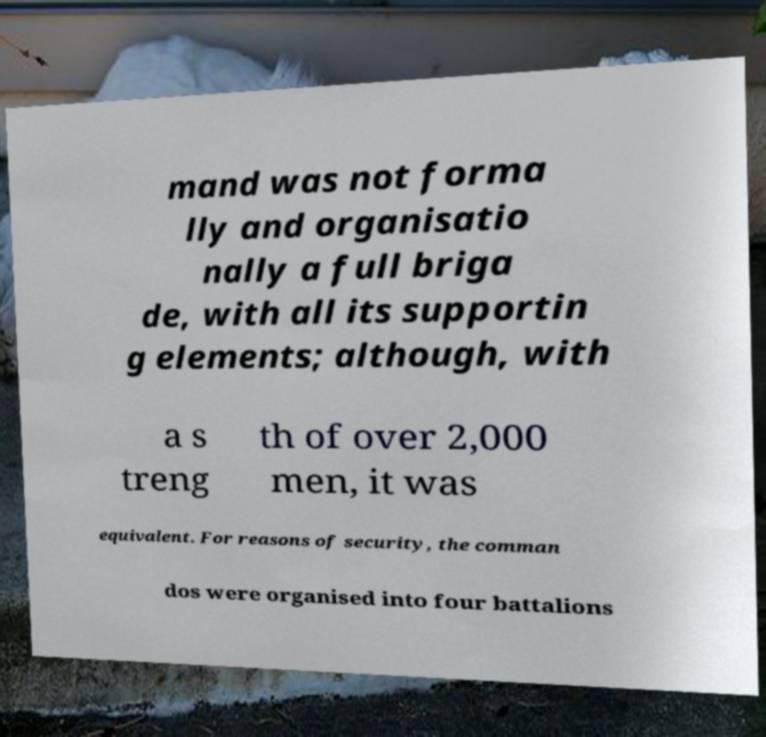Could you extract and type out the text from this image? mand was not forma lly and organisatio nally a full briga de, with all its supportin g elements; although, with a s treng th of over 2,000 men, it was equivalent. For reasons of security, the comman dos were organised into four battalions 